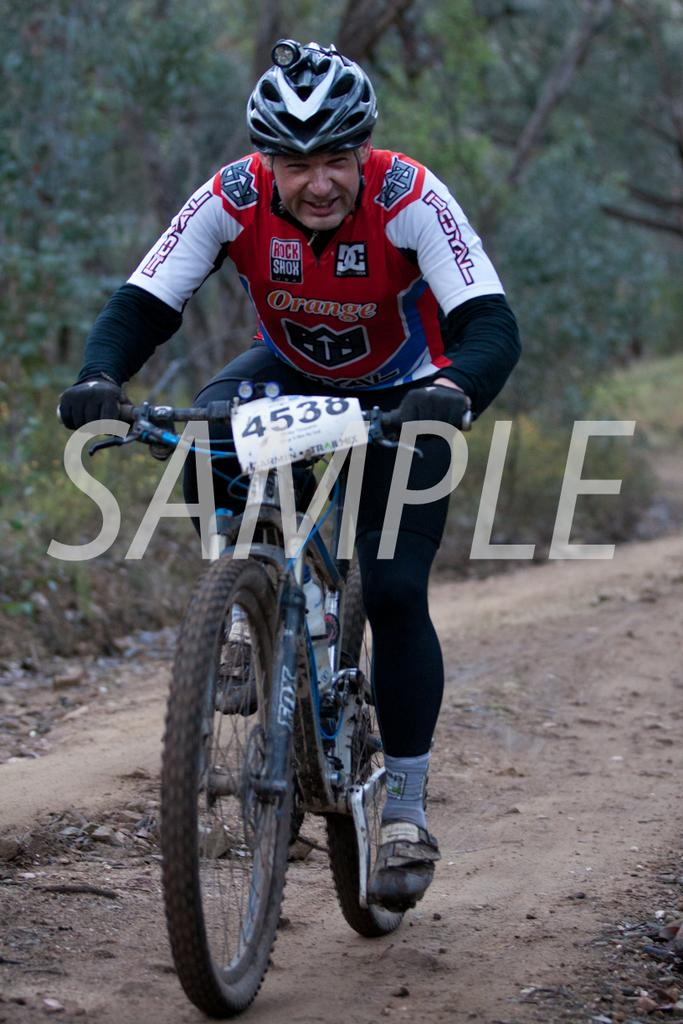Who is in the image? There is a man in the image. What is the man doing in the image? The man is sitting on a bicycle. What safety precaution is the man taking in the image? The man is wearing a helmet. What can be seen in the background of the image? There are trees, plants, and a road in the background of the image. What advice is the man giving to the pigs in the field in the image? There are no pigs or fields present in the image; it features a man sitting on a bicycle with a helmet on. 